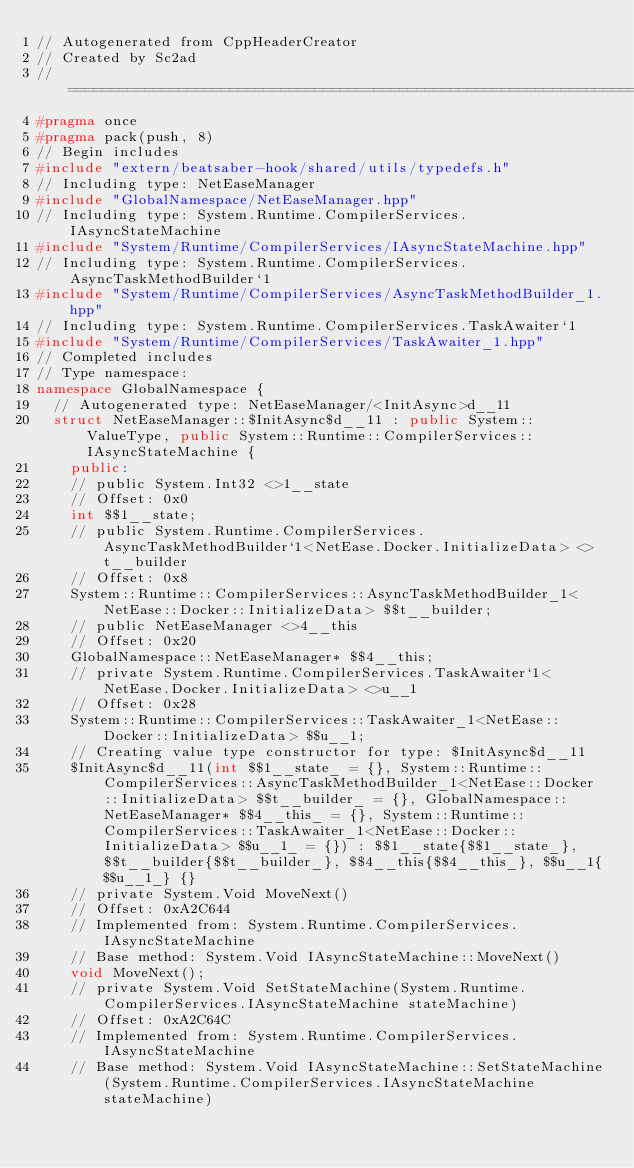<code> <loc_0><loc_0><loc_500><loc_500><_C++_>// Autogenerated from CppHeaderCreator
// Created by Sc2ad
// =========================================================================
#pragma once
#pragma pack(push, 8)
// Begin includes
#include "extern/beatsaber-hook/shared/utils/typedefs.h"
// Including type: NetEaseManager
#include "GlobalNamespace/NetEaseManager.hpp"
// Including type: System.Runtime.CompilerServices.IAsyncStateMachine
#include "System/Runtime/CompilerServices/IAsyncStateMachine.hpp"
// Including type: System.Runtime.CompilerServices.AsyncTaskMethodBuilder`1
#include "System/Runtime/CompilerServices/AsyncTaskMethodBuilder_1.hpp"
// Including type: System.Runtime.CompilerServices.TaskAwaiter`1
#include "System/Runtime/CompilerServices/TaskAwaiter_1.hpp"
// Completed includes
// Type namespace: 
namespace GlobalNamespace {
  // Autogenerated type: NetEaseManager/<InitAsync>d__11
  struct NetEaseManager::$InitAsync$d__11 : public System::ValueType, public System::Runtime::CompilerServices::IAsyncStateMachine {
    public:
    // public System.Int32 <>1__state
    // Offset: 0x0
    int $$1__state;
    // public System.Runtime.CompilerServices.AsyncTaskMethodBuilder`1<NetEase.Docker.InitializeData> <>t__builder
    // Offset: 0x8
    System::Runtime::CompilerServices::AsyncTaskMethodBuilder_1<NetEase::Docker::InitializeData> $$t__builder;
    // public NetEaseManager <>4__this
    // Offset: 0x20
    GlobalNamespace::NetEaseManager* $$4__this;
    // private System.Runtime.CompilerServices.TaskAwaiter`1<NetEase.Docker.InitializeData> <>u__1
    // Offset: 0x28
    System::Runtime::CompilerServices::TaskAwaiter_1<NetEase::Docker::InitializeData> $$u__1;
    // Creating value type constructor for type: $InitAsync$d__11
    $InitAsync$d__11(int $$1__state_ = {}, System::Runtime::CompilerServices::AsyncTaskMethodBuilder_1<NetEase::Docker::InitializeData> $$t__builder_ = {}, GlobalNamespace::NetEaseManager* $$4__this_ = {}, System::Runtime::CompilerServices::TaskAwaiter_1<NetEase::Docker::InitializeData> $$u__1_ = {}) : $$1__state{$$1__state_}, $$t__builder{$$t__builder_}, $$4__this{$$4__this_}, $$u__1{$$u__1_} {}
    // private System.Void MoveNext()
    // Offset: 0xA2C644
    // Implemented from: System.Runtime.CompilerServices.IAsyncStateMachine
    // Base method: System.Void IAsyncStateMachine::MoveNext()
    void MoveNext();
    // private System.Void SetStateMachine(System.Runtime.CompilerServices.IAsyncStateMachine stateMachine)
    // Offset: 0xA2C64C
    // Implemented from: System.Runtime.CompilerServices.IAsyncStateMachine
    // Base method: System.Void IAsyncStateMachine::SetStateMachine(System.Runtime.CompilerServices.IAsyncStateMachine stateMachine)</code> 